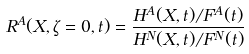Convert formula to latex. <formula><loc_0><loc_0><loc_500><loc_500>R ^ { A } ( X , \zeta = 0 , t ) = \frac { H ^ { A } ( X , t ) / F ^ { A } ( t ) } { H ^ { N } ( X , t ) / F ^ { N } ( t ) }</formula> 